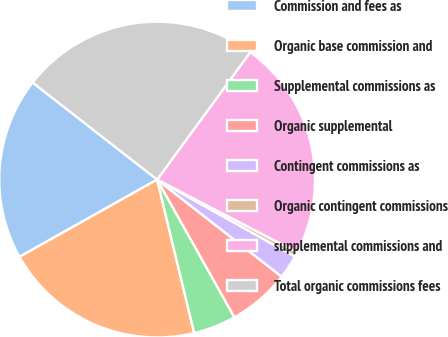Convert chart to OTSL. <chart><loc_0><loc_0><loc_500><loc_500><pie_chart><fcel>Commission and fees as<fcel>Organic base commission and<fcel>Supplemental commissions as<fcel>Organic supplemental<fcel>Contingent commissions as<fcel>Organic contingent commissions<fcel>supplemental commissions and<fcel>Total organic commissions fees<nl><fcel>18.68%<fcel>20.63%<fcel>4.37%<fcel>6.32%<fcel>2.43%<fcel>0.49%<fcel>22.57%<fcel>24.51%<nl></chart> 